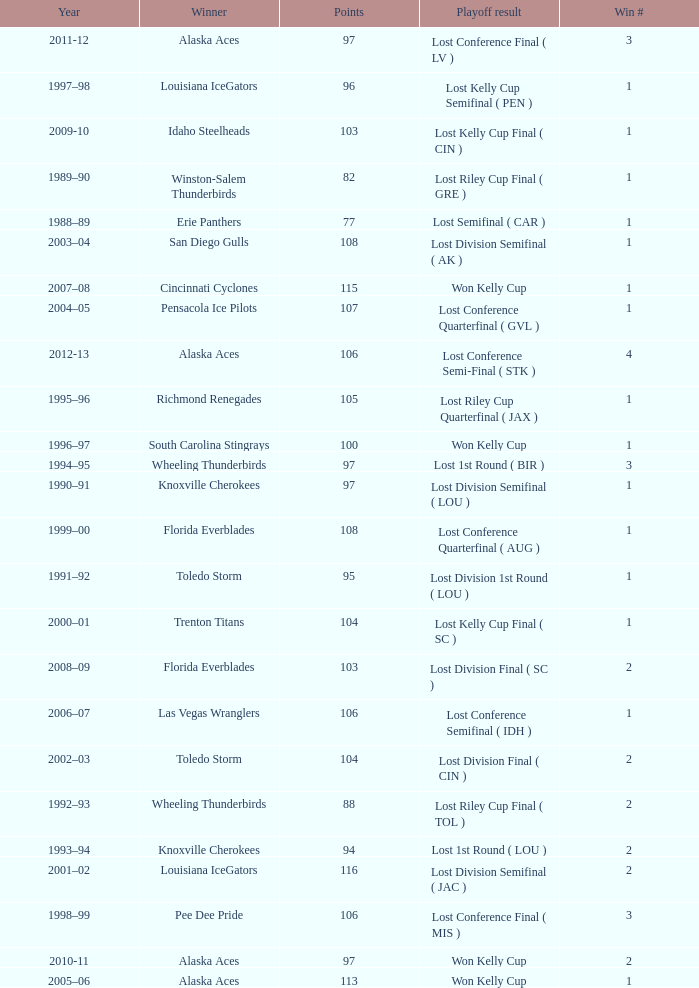What is the highest Win #, when Winner is "Knoxville Cherokees", when Playoff Result is "Lost 1st Round ( LOU )", and when Points is less than 94? None. 